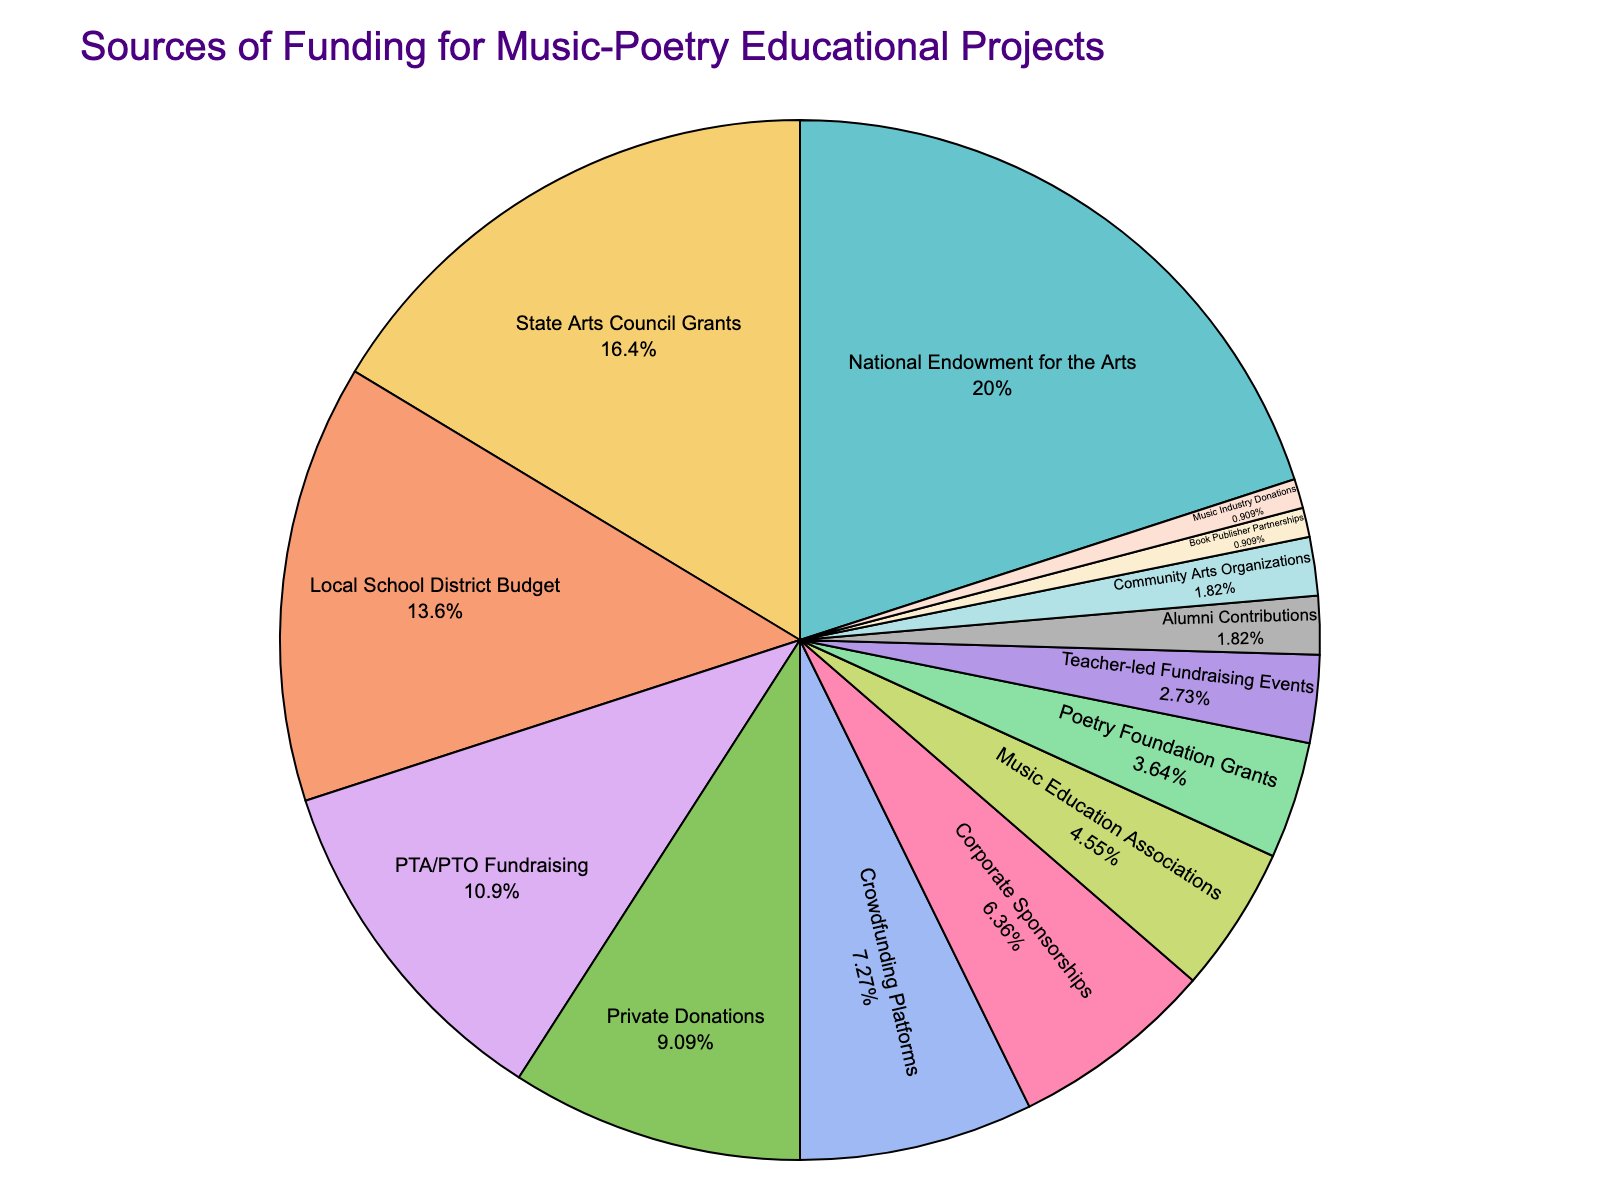What percentage of total funding is sourced from private donations and crowdfunding platforms combined? To determine the total percentage of funding from private donations and crowdfunding platforms, add the percentages given: Private Donations (10%) + Crowdfunding Platforms (8%) = 10% + 8%
Answer: 18% Which funding source contributes more to the project, PTA/PTO Fundraising or Corporate Sponsorships? To determine which source contributes more, compare their percentages: PTA/PTO Fundraising (12%) and Corporate Sponsorships (7%). PTA/PTO Fundraising has a higher percentage.
Answer: PTA/PTO Fundraising What is the smallest source of funding, and what is its percentage contribution? The smallest source of funding is identified by the lowest percentage value in the list. Book Publisher Partnerships and Music Industry Donations each contribute 1%.
Answer: Book Publisher Partnerships and Music Industry Donations, each 1% Which source of funding offers the greatest contribution and by what percentage? The greatest contribution is identified by the highest percentage: National Endowment for the Arts (22%).
Answer: National Endowment for the Arts, 22% How does the funding from local school district budgets compare to that from state arts council grants? Compare the percentages for Local School District Budget (15%) and State Arts Council Grants (18%). The State Arts Council Grants contribute more.
Answer: State Arts Council Grants contributes 3% more than Local School District Budget What is the combined percentage of funding from corporate sponsorships, music education associations, and poetry foundation grants? Add the percentages from Corporate Sponsorships (7%), Music Education Associations (5%), and Poetry Foundation Grants (4%): 7% + 5% + 4% = 16%
Answer: 16% What are the total contributions from the sources with less than 5% funding each? Identify sources with less than 5% funding and sum their contributions: Poetry Foundation Grants (4%), Teacher-led Fundraising Events (3%), Alumni Contributions (2%), Community Arts Organizations (2%), Book Publisher Partnerships (1%), and Music Industry Donations (1%). 4% + 3% + 2% + 2% + 1% + 1% = 13%
Answer: 13% Compare the funding from National Endowment for the Arts with that from Local School District Budget and Crowdfunding Platforms combined. First, sum the contributions from Local School District Budget (15%) and Crowdfunding Platforms (8%) = 15% + 8% = 23%. Compare this to National Endowment for the Arts (22%). 23% (combined) is greater than 22%.
Answer: Local School District Budget and Crowdfunding Platforms combined, 23%, is greater than National Endowment for the Arts, 22% Which sources contribute more than 10% individually? Identify each source with a contribution greater than 10%: National Endowment for the Arts (22%), State Arts Council Grants (18%), and Local School District Budget (15%), PTA/PTO Fundraising (12%).
Answer: National Endowment for the Arts, State Arts Council Grants, Local School District Budget, PTA/PTO Fundraising 